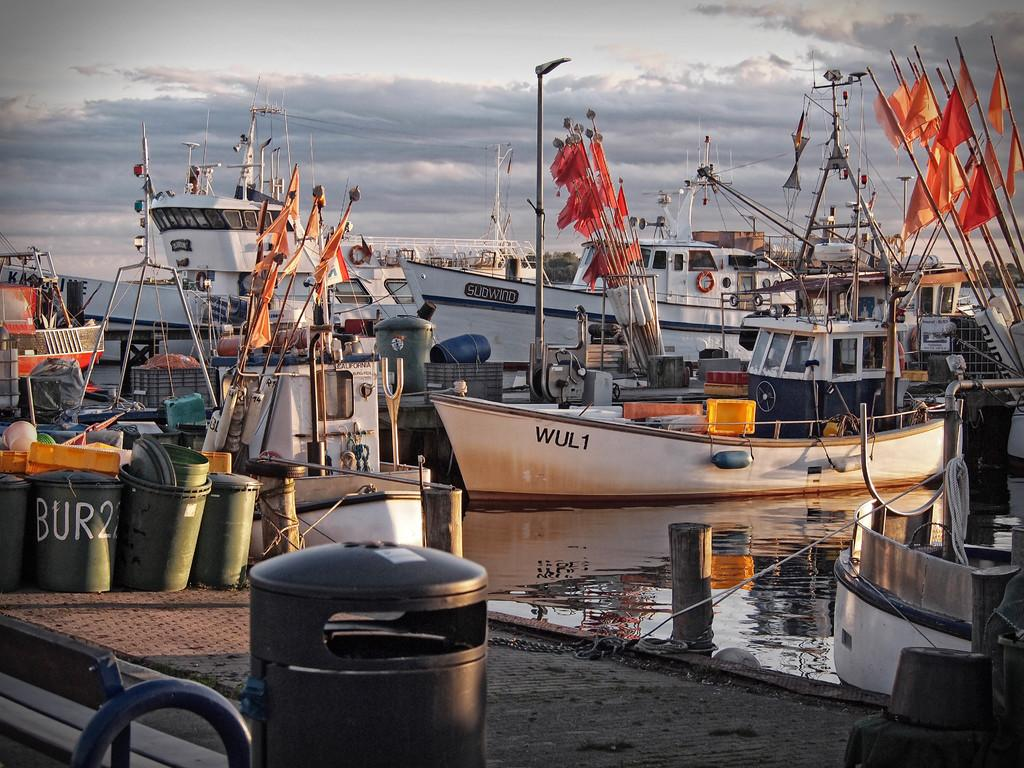<image>
Relay a brief, clear account of the picture shown. Boats marked "Sudwind" and ""WUL1" sit in a dock near a barrel painted with the text "Bur22." 